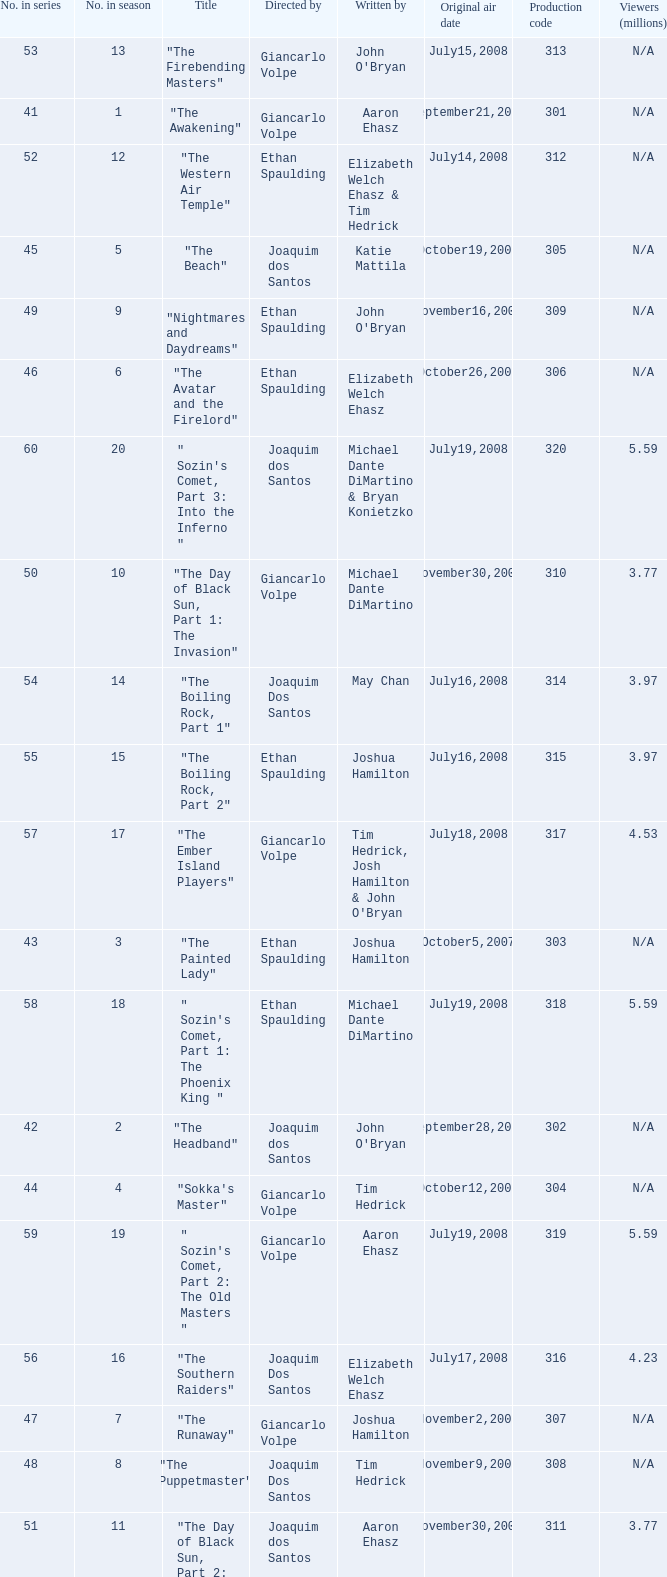What season has an episode written by john o'bryan and directed by ethan spaulding? 9.0. 